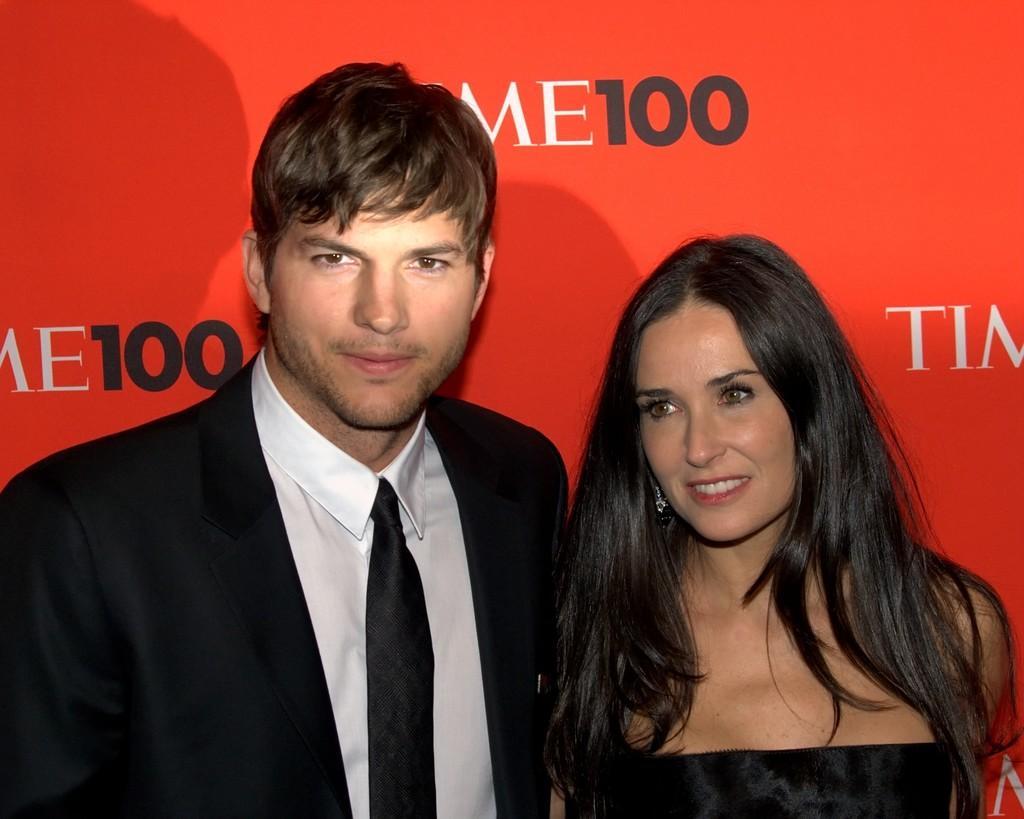How would you summarize this image in a sentence or two? In the foreground of this image, there is a couple standing in front of a red banner wall. 